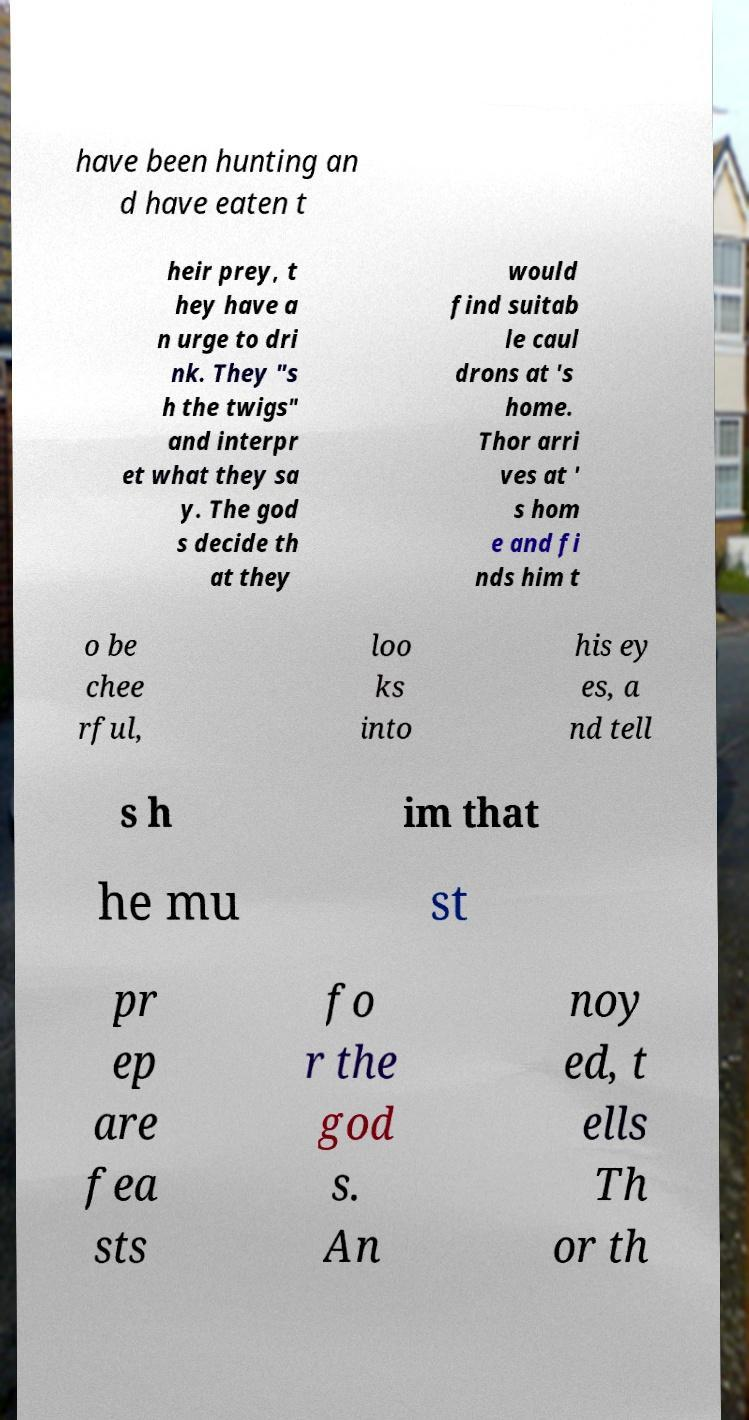Please read and relay the text visible in this image. What does it say? have been hunting an d have eaten t heir prey, t hey have a n urge to dri nk. They "s h the twigs" and interpr et what they sa y. The god s decide th at they would find suitab le caul drons at 's home. Thor arri ves at ' s hom e and fi nds him t o be chee rful, loo ks into his ey es, a nd tell s h im that he mu st pr ep are fea sts fo r the god s. An noy ed, t ells Th or th 